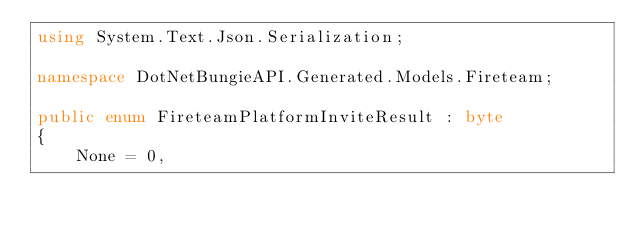<code> <loc_0><loc_0><loc_500><loc_500><_C#_>using System.Text.Json.Serialization;

namespace DotNetBungieAPI.Generated.Models.Fireteam;

public enum FireteamPlatformInviteResult : byte
{
    None = 0,</code> 